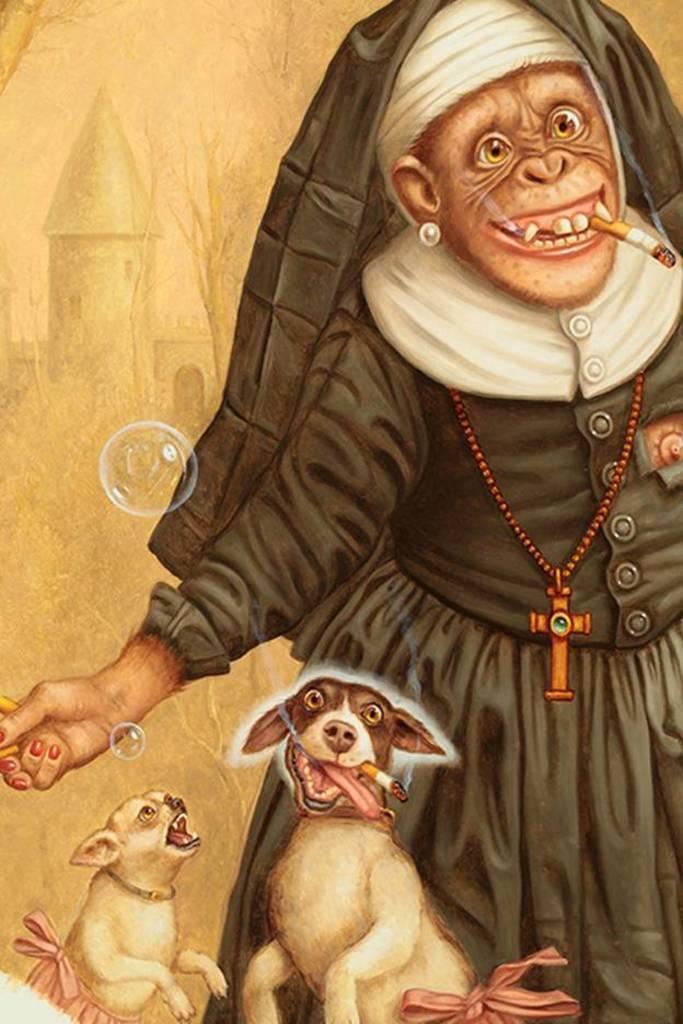In one or two sentences, can you explain what this image depicts? In this image I see the depiction of 2 dogs and I see that this monkey is wearing a dress which is of white and black in color and I see bubbles and I see that this dog and this money are having cigarettes in their mouths. 